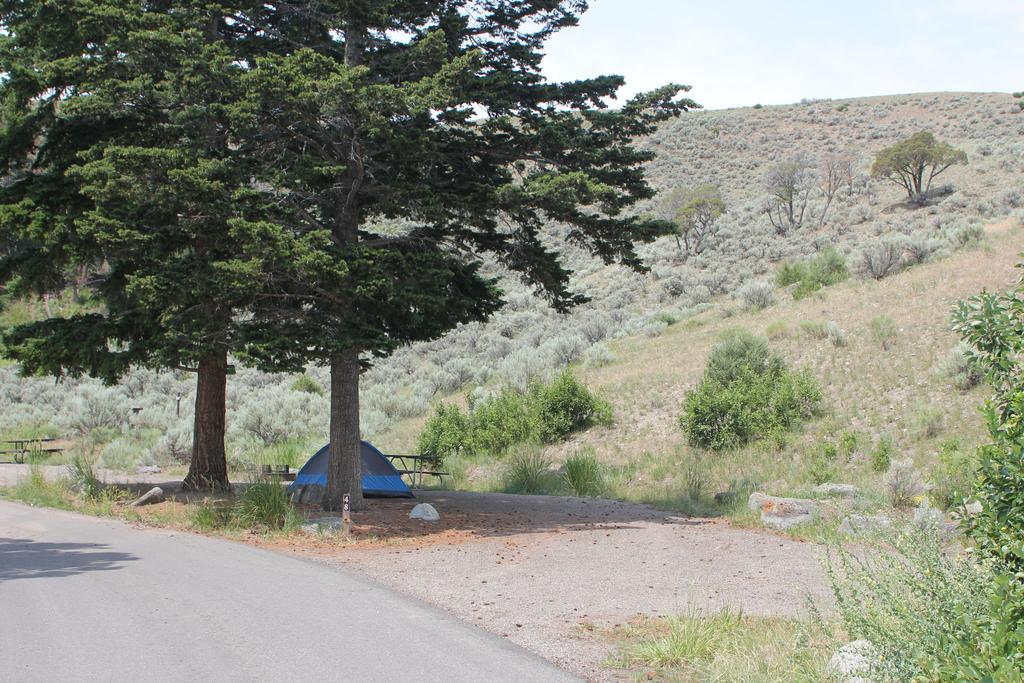What type of vegetation can be seen in the image? There are trees and plants on the ground in the image. What type of structure is present on the ground in the image? There is a tent on the ground in the image. What type of seating is available in the image? There are benches in the image. What is the condition of the sky in the image? The sky is cloudy in the image. What type of car can be seen driving through the image? There is no car present in the image; it features trees, plants, a tent, benches, and a cloudy sky. What color is the button on the tent in the image? There is no button present on the tent in the image. 